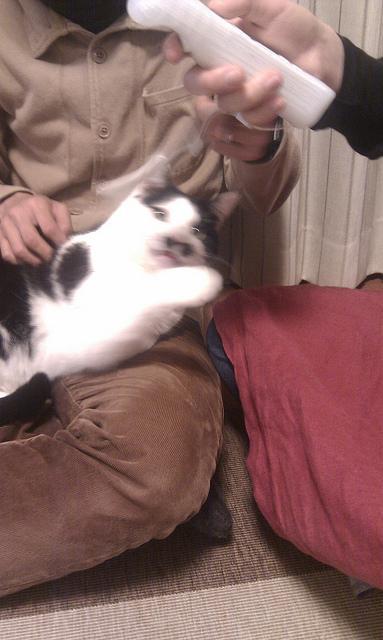How many people can you see?
Give a very brief answer. 2. How many cats can you see?
Give a very brief answer. 1. 